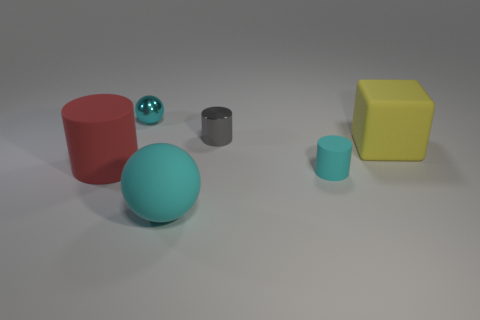Add 3 large cylinders. How many objects exist? 9 Subtract all cubes. How many objects are left? 5 Add 6 cyan cylinders. How many cyan cylinders exist? 7 Subtract 0 blue balls. How many objects are left? 6 Subtract all tiny yellow things. Subtract all large matte objects. How many objects are left? 3 Add 4 large cyan spheres. How many large cyan spheres are left? 5 